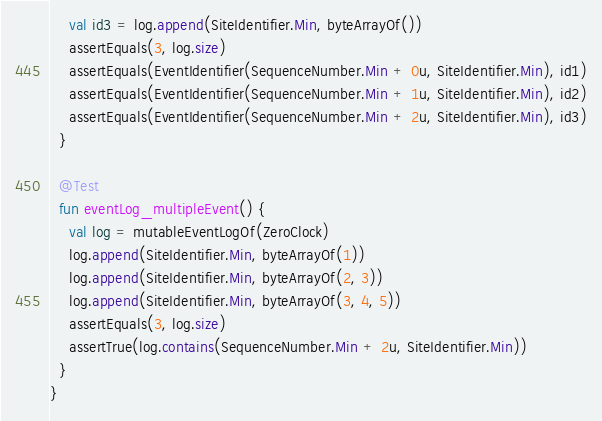Convert code to text. <code><loc_0><loc_0><loc_500><loc_500><_Kotlin_>    val id3 = log.append(SiteIdentifier.Min, byteArrayOf())
    assertEquals(3, log.size)
    assertEquals(EventIdentifier(SequenceNumber.Min + 0u, SiteIdentifier.Min), id1)
    assertEquals(EventIdentifier(SequenceNumber.Min + 1u, SiteIdentifier.Min), id2)
    assertEquals(EventIdentifier(SequenceNumber.Min + 2u, SiteIdentifier.Min), id3)
  }

  @Test
  fun eventLog_multipleEvent() {
    val log = mutableEventLogOf(ZeroClock)
    log.append(SiteIdentifier.Min, byteArrayOf(1))
    log.append(SiteIdentifier.Min, byteArrayOf(2, 3))
    log.append(SiteIdentifier.Min, byteArrayOf(3, 4, 5))
    assertEquals(3, log.size)
    assertTrue(log.contains(SequenceNumber.Min + 2u, SiteIdentifier.Min))
  }
}
</code> 